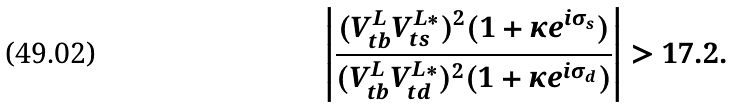Convert formula to latex. <formula><loc_0><loc_0><loc_500><loc_500>\left | \frac { ( V _ { t b } ^ { L } V _ { t s } ^ { L * } ) ^ { 2 } ( 1 + \kappa e ^ { i \sigma _ { s } } ) } { ( V _ { t b } ^ { L } V _ { t d } ^ { L * } ) ^ { 2 } ( 1 + \kappa e ^ { i \sigma _ { d } } ) } \right | > 1 7 . 2 .</formula> 